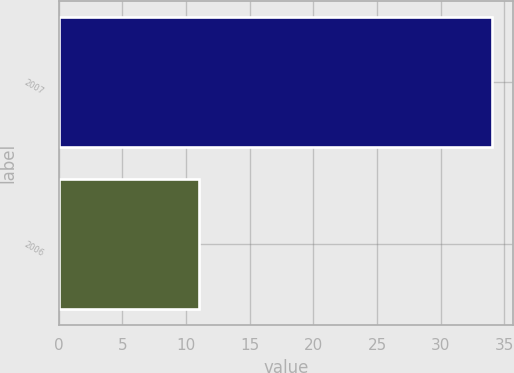Convert chart to OTSL. <chart><loc_0><loc_0><loc_500><loc_500><bar_chart><fcel>2007<fcel>2006<nl><fcel>34<fcel>11<nl></chart> 